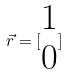<formula> <loc_0><loc_0><loc_500><loc_500>\vec { r } = [ \begin{matrix} 1 \\ 0 \end{matrix} ]</formula> 